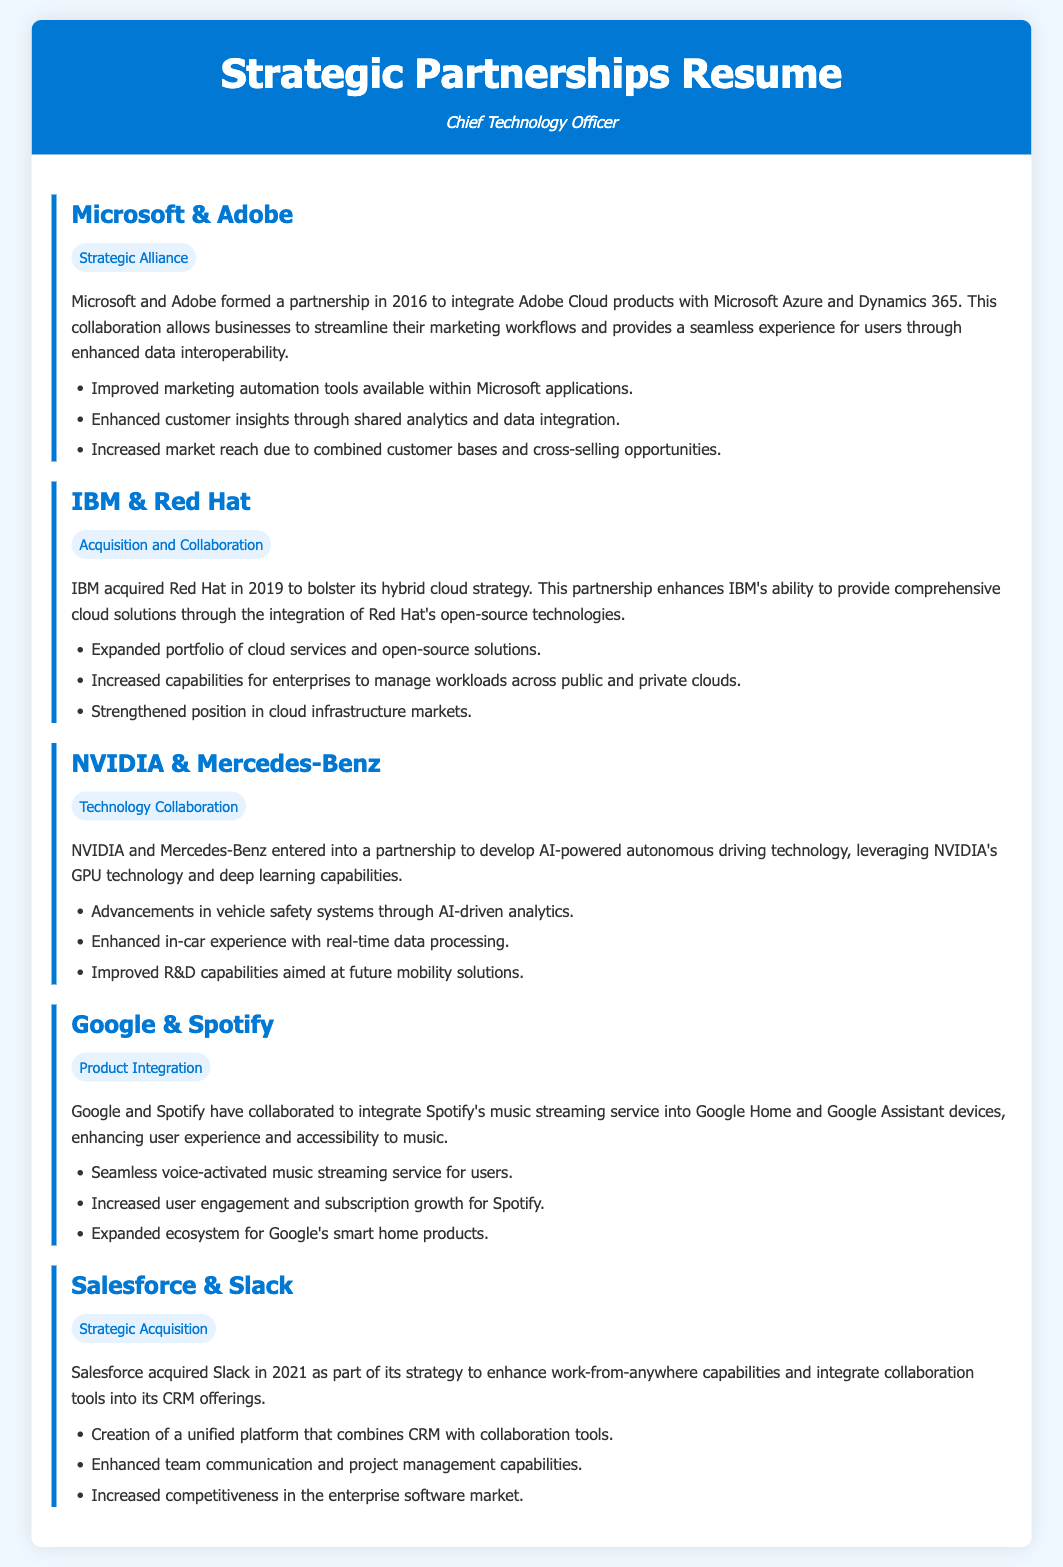What year was the partnership between Microsoft and Adobe formed? The document states that Microsoft and Adobe formed their partnership in 2016.
Answer: 2016 What technology does NVIDIA use in its partnership with Mercedes-Benz? The document mentions that NVIDIA leverages its GPU technology for AI-powered autonomous driving technology.
Answer: GPU technology What type of collaboration is highlighted in the partnership between IBM and Red Hat? The document describes the collaboration as an "Acquisition and Collaboration."
Answer: Acquisition and Collaboration Which platform did Salesforce acquire to enhance work-from-anywhere capabilities? The document states that Salesforce acquired Slack in 2021 for this purpose.
Answer: Slack What key enhancement was achieved through the partnership between Google and Spotify? The document indicates that the integration enhanced user experience and accessibility to music.
Answer: User experience How did the partnership between Microsoft and Adobe help their marketing tools? The document notes that it provided improved marketing automation tools within Microsoft applications.
Answer: Improved marketing automation tools What was the main focus of the IBM and Red Hat partnership? The document highlights that the focus was to bolster IBM's hybrid cloud strategy.
Answer: Hybrid cloud strategy What kind of technology collaboration did NVIDIA and Mercedes-Benz pursue? The collaboration focused on developing AI-powered autonomous driving technology.
Answer: AI-powered autonomous driving technology What was a result of the Google and Spotify collaboration regarding user engagement? The document states that it led to increased user engagement and subscription growth for Spotify.
Answer: Increased user engagement 